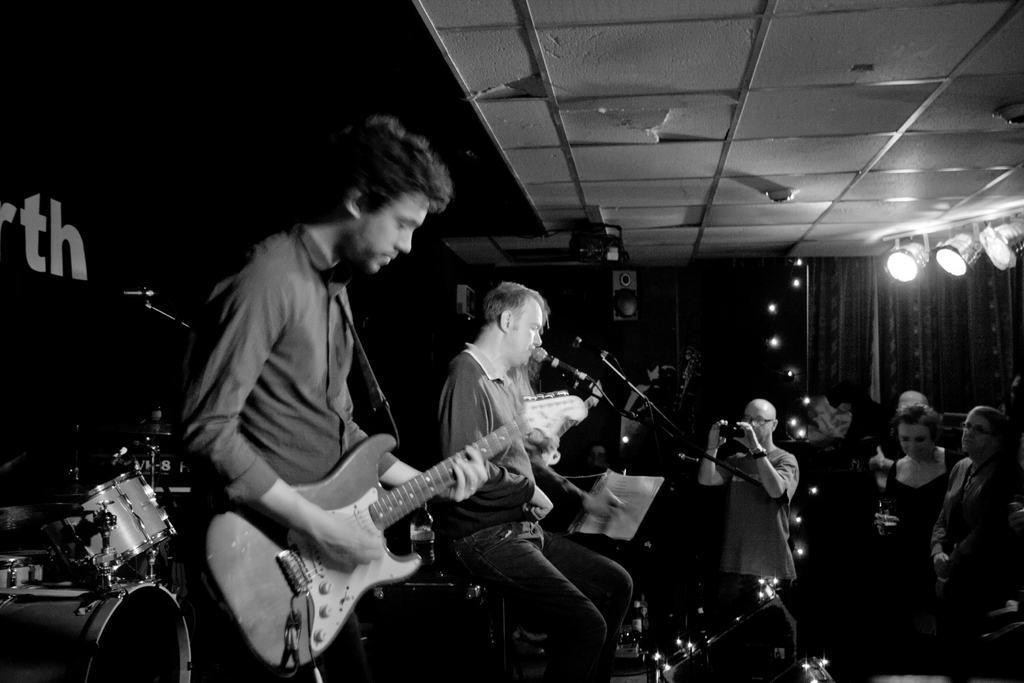Please provide a concise description of this image. In this image i can see two man a man standing at front is playing a guitar a man sitting beside is singing in front of a micro phone there are few other people standing and holding a camera at the back ground there are some musical instrument a wall, a curtain at the top there is a light. 